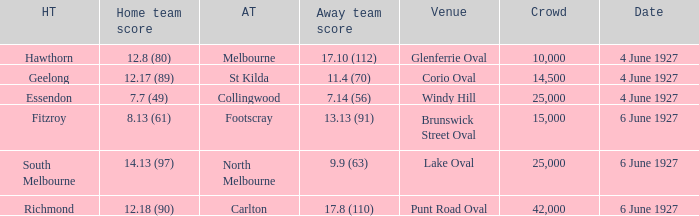How many people in the crowd with north melbourne as an away team? 25000.0. 